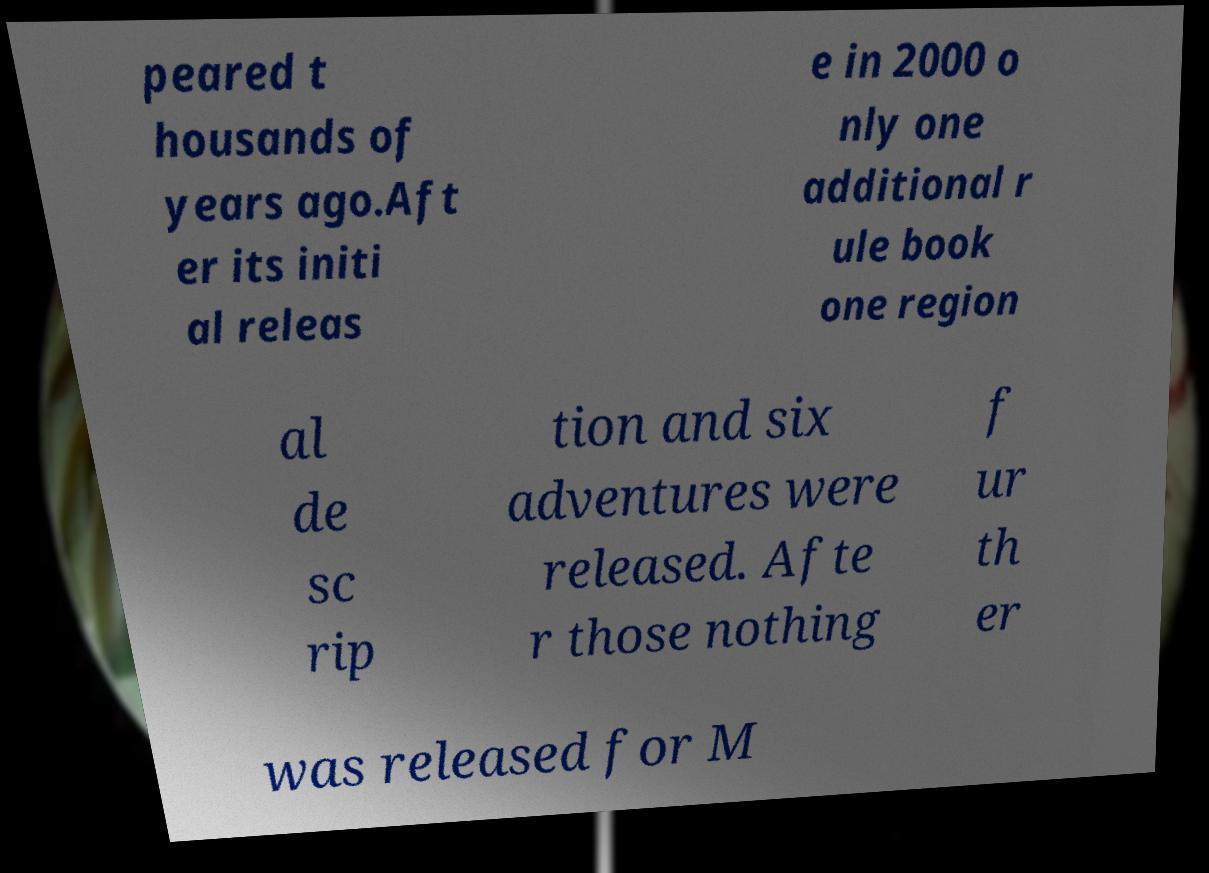Could you extract and type out the text from this image? peared t housands of years ago.Aft er its initi al releas e in 2000 o nly one additional r ule book one region al de sc rip tion and six adventures were released. Afte r those nothing f ur th er was released for M 